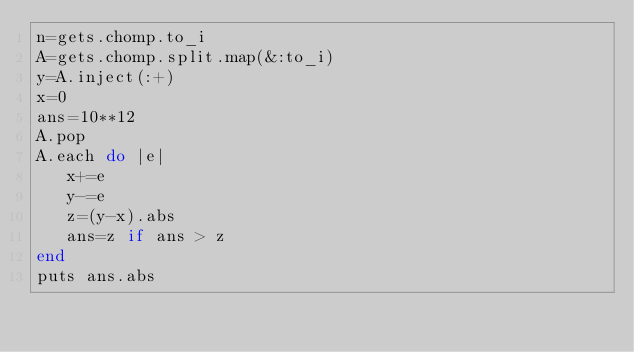Convert code to text. <code><loc_0><loc_0><loc_500><loc_500><_Ruby_>n=gets.chomp.to_i
A=gets.chomp.split.map(&:to_i)
y=A.inject(:+)
x=0
ans=10**12
A.pop
A.each do |e|
   x+=e
   y-=e
   z=(y-x).abs
   ans=z if ans > z
end
puts ans.abs</code> 